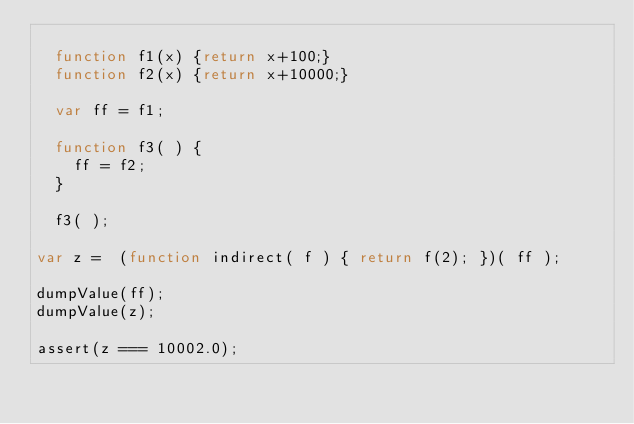Convert code to text. <code><loc_0><loc_0><loc_500><loc_500><_JavaScript_>
  function f1(x) {return x+100;}
  function f2(x) {return x+10000;}

  var ff = f1;

  function f3( ) {
    ff = f2;
  }

  f3( );

var z =  (function indirect( f ) { return f(2); })( ff );

dumpValue(ff);
dumpValue(z);

assert(z === 10002.0);</code> 